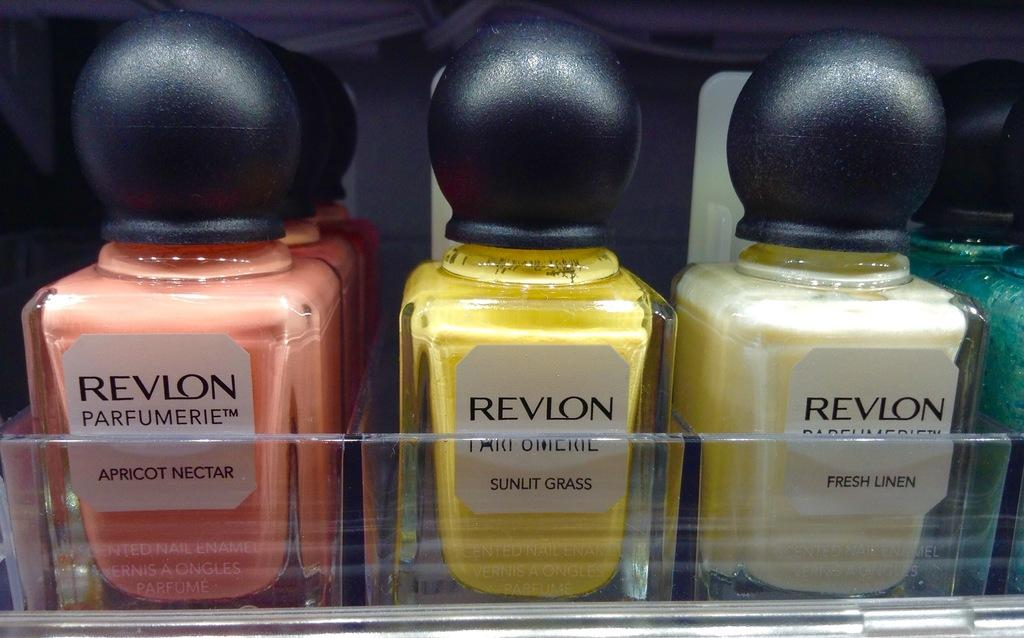<image>
Give a short and clear explanation of the subsequent image. Many bottles of Revlon nail polish in a display. 